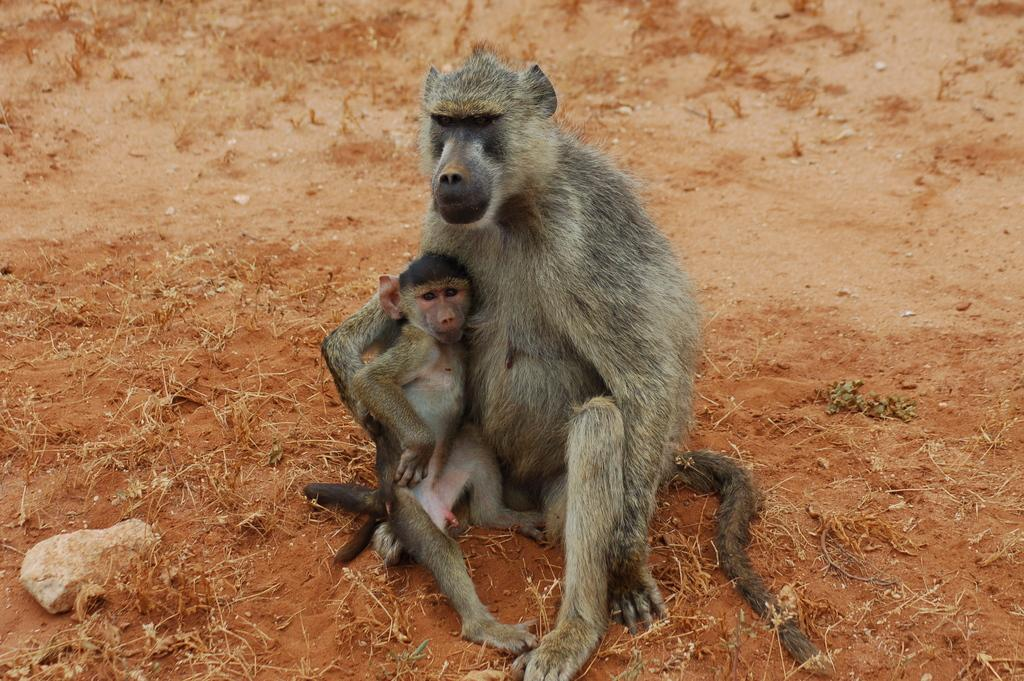What is the monkey doing in the image? The monkey is sitting on the ground and holding a baby monkey in its arms. What can be seen on the ground near the monkey? There is a stone on the ground to the left. How many monkeys are visible in the image? There are two monkeys visible in the image, the adult monkey and the baby monkey. What type of dolls can be seen in the image? There are no dolls present in the image; it features a monkey holding a baby monkey. 